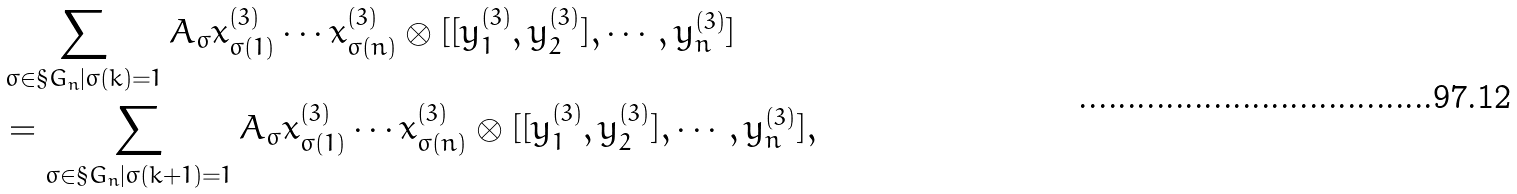Convert formula to latex. <formula><loc_0><loc_0><loc_500><loc_500>& \sum _ { \sigma \in \S G _ { n } | \sigma ( k ) = 1 } A _ { \sigma } x ^ { ( 3 ) } _ { \sigma ( 1 ) } \cdots x ^ { ( 3 ) } _ { \sigma ( n ) } \otimes [ [ y ^ { ( 3 ) } _ { 1 } , y ^ { ( 3 ) } _ { 2 } ] , \cdots , y ^ { ( 3 ) } _ { n } ] \\ & = \sum _ { \sigma \in \S G _ { n } | \sigma ( k + 1 ) = 1 } A _ { \sigma } x ^ { ( 3 ) } _ { \sigma ( 1 ) } \cdots x ^ { ( 3 ) } _ { \sigma ( n ) } \otimes [ [ y ^ { ( 3 ) } _ { 1 } , y ^ { ( 3 ) } _ { 2 } ] , \cdots , y ^ { ( 3 ) } _ { n } ] ,</formula> 